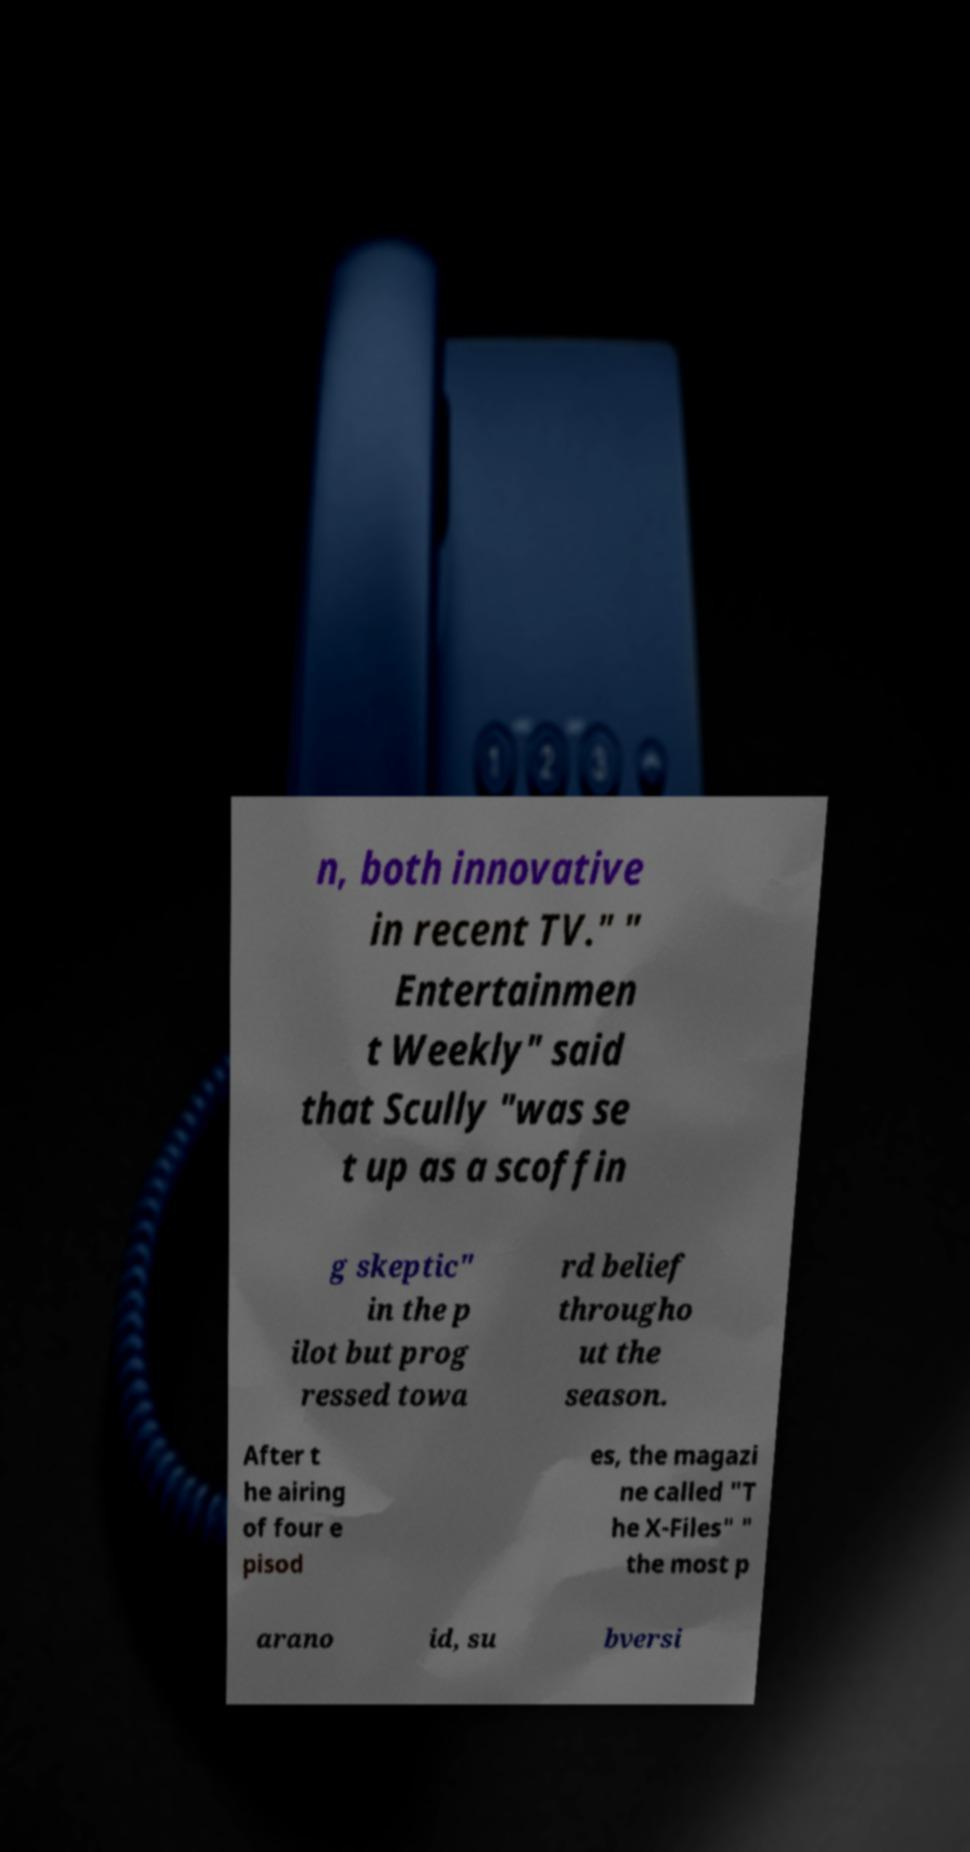There's text embedded in this image that I need extracted. Can you transcribe it verbatim? n, both innovative in recent TV." " Entertainmen t Weekly" said that Scully "was se t up as a scoffin g skeptic" in the p ilot but prog ressed towa rd belief througho ut the season. After t he airing of four e pisod es, the magazi ne called "T he X-Files" " the most p arano id, su bversi 